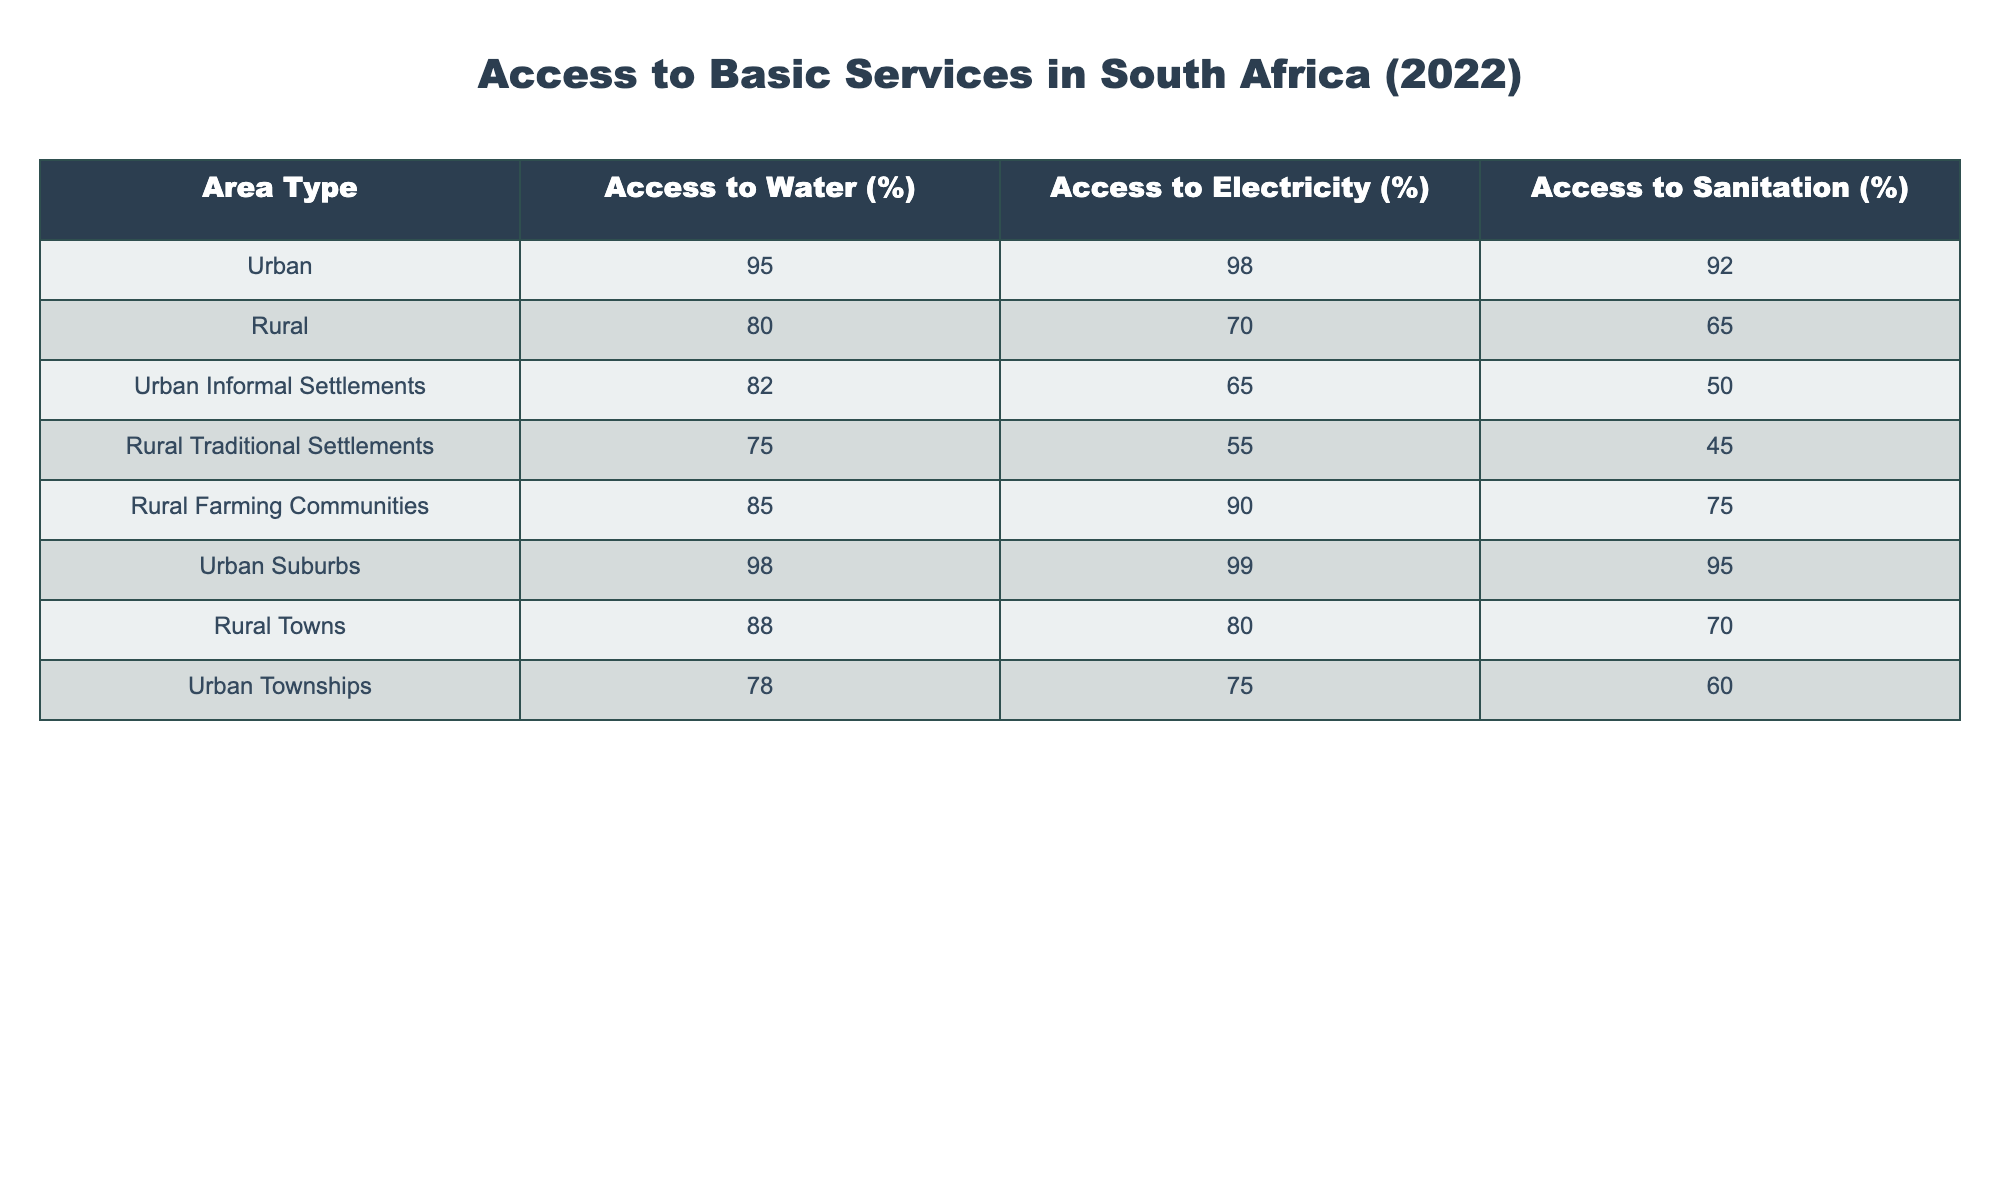What percentage of urban areas have access to electricity? The corresponding row for urban areas shows an access percentage of 98% for electricity.
Answer: 98% What is the access percentage to sanitation in rural farming communities? By checking the row for rural farming communities, the access percentage to sanitation is 75%.
Answer: 75% Which area type has the lowest access to sanitation? Examining the sanitation access percentages across all area types, rural traditional settlements show the lowest at 45%.
Answer: 45% What is the difference in access to water between urban informal settlements and rural traditional settlements? Access to water in urban informal settlements is 82%, while in rural traditional settlements, it is 75%. The difference is 82% - 75% = 7%.
Answer: 7% Do more than 80% of urban township residents have access to electricity? Checking the percentage, urban townships have access to electricity at 75%, which is not more than 80%.
Answer: No What is the average access to sanitation for rural areas? The access percentages for sanitation in rural areas are 65% for rural, 45% for rural traditional settlements, 75% for rural farming communities, and 70% for rural towns. The sum is 65 + 45 + 75 + 70 = 255, and there are 4 areas, so the average is 255 / 4 = 63.75%.
Answer: 63.75% Which area type has the highest access to water? The area type with the highest access to water is urban suburbs at 98%.
Answer: 98% Is it true that access to electricity in urban informal settlements is higher than in rural traditional settlements? Access to electricity in urban informal settlements is 65%, while in rural traditional settlements it's 55%. Hence, it is true that urban informal settlements have higher access.
Answer: Yes What is the overall access to electricity for rural towns and rural traditional settlements combined? The electricity access for rural towns is 80% and for rural traditional settlements is 55%. The combined access is (80 + 55) / 2 = 67.5%.
Answer: 67.5% 